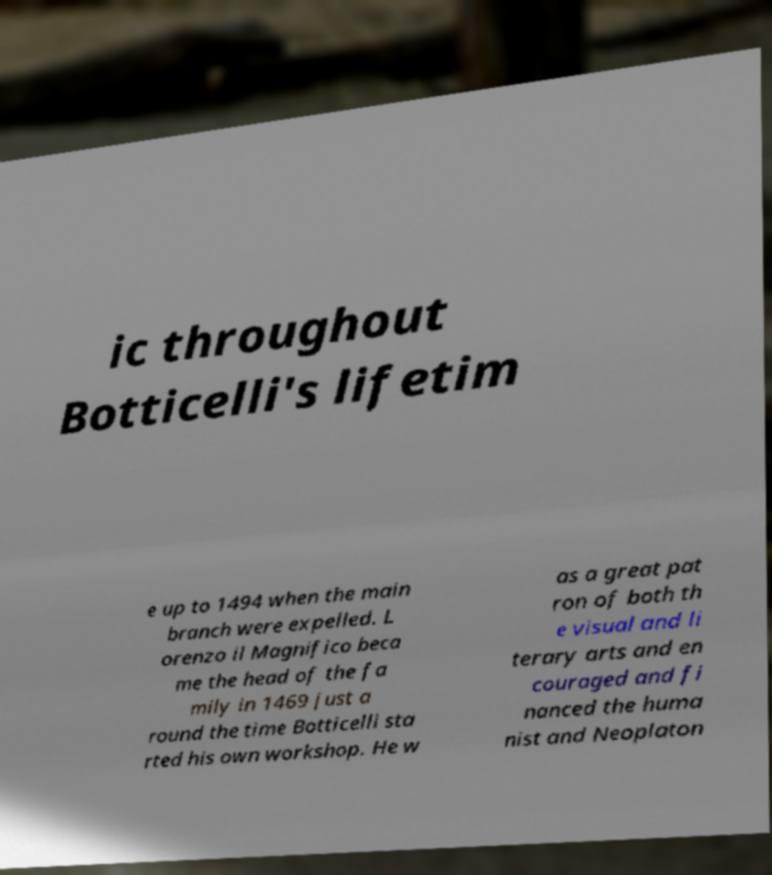Can you accurately transcribe the text from the provided image for me? ic throughout Botticelli's lifetim e up to 1494 when the main branch were expelled. L orenzo il Magnifico beca me the head of the fa mily in 1469 just a round the time Botticelli sta rted his own workshop. He w as a great pat ron of both th e visual and li terary arts and en couraged and fi nanced the huma nist and Neoplaton 